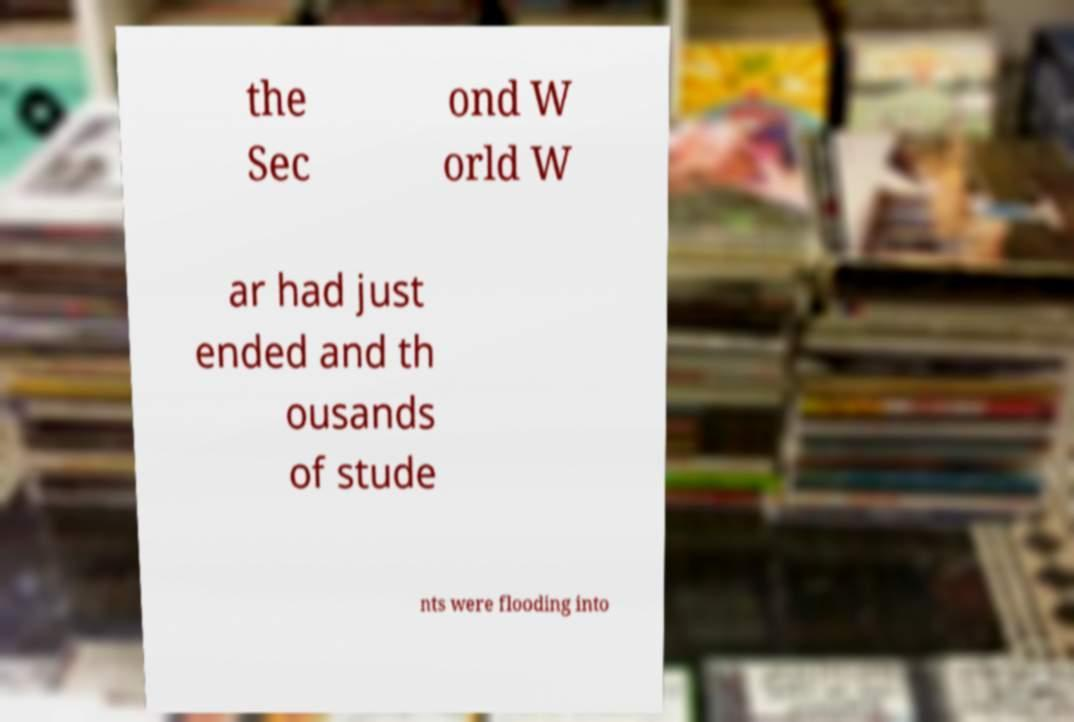Could you assist in decoding the text presented in this image and type it out clearly? the Sec ond W orld W ar had just ended and th ousands of stude nts were flooding into 